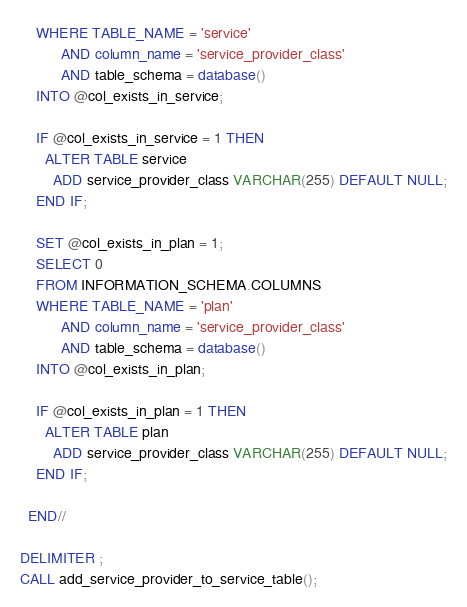<code> <loc_0><loc_0><loc_500><loc_500><_SQL_>    WHERE TABLE_NAME = 'service'
          AND column_name = 'service_provider_class'
          AND table_schema = database()
    INTO @col_exists_in_service;

    IF @col_exists_in_service = 1 THEN
      ALTER TABLE service
        ADD service_provider_class VARCHAR(255) DEFAULT NULL;
    END IF;

    SET @col_exists_in_plan = 1;
    SELECT 0
    FROM INFORMATION_SCHEMA.COLUMNS
    WHERE TABLE_NAME = 'plan'
          AND column_name = 'service_provider_class'
          AND table_schema = database()
    INTO @col_exists_in_plan;

    IF @col_exists_in_plan = 1 THEN
      ALTER TABLE plan
        ADD service_provider_class VARCHAR(255) DEFAULT NULL;
    END IF;

  END//

DELIMITER ;
CALL add_service_provider_to_service_table();</code> 